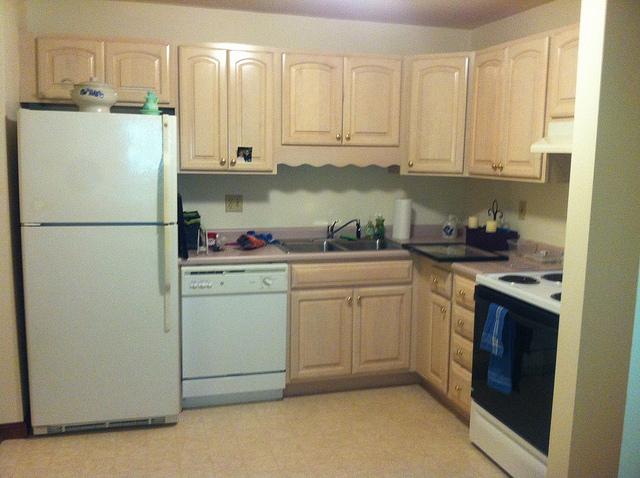What room is this?
Be succinct. Kitchen. Is this a modern kitchen?
Short answer required. Yes. What is on the fridge?
Quick response, please. Pot. How many appliances is there?
Concise answer only. 3. What color are the cabinets?
Be succinct. Beige. 